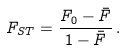<formula> <loc_0><loc_0><loc_500><loc_500>F _ { S T } = \frac { F _ { 0 } - \bar { F } } { 1 - \bar { F } } \, .</formula> 